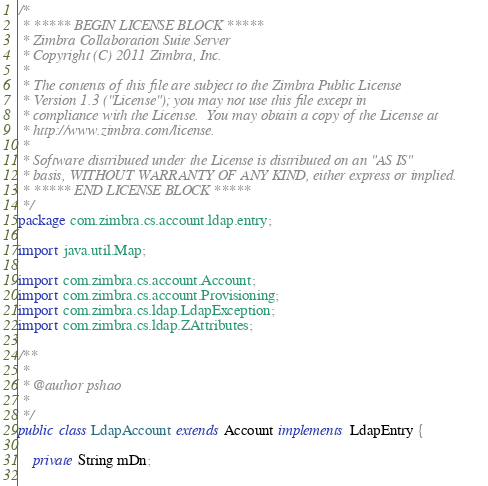Convert code to text. <code><loc_0><loc_0><loc_500><loc_500><_Java_>/*
 * ***** BEGIN LICENSE BLOCK *****
 * Zimbra Collaboration Suite Server
 * Copyright (C) 2011 Zimbra, Inc.
 * 
 * The contents of this file are subject to the Zimbra Public License
 * Version 1.3 ("License"); you may not use this file except in
 * compliance with the License.  You may obtain a copy of the License at
 * http://www.zimbra.com/license.
 * 
 * Software distributed under the License is distributed on an "AS IS"
 * basis, WITHOUT WARRANTY OF ANY KIND, either express or implied.
 * ***** END LICENSE BLOCK *****
 */
package com.zimbra.cs.account.ldap.entry;

import java.util.Map;

import com.zimbra.cs.account.Account;
import com.zimbra.cs.account.Provisioning;
import com.zimbra.cs.ldap.LdapException;
import com.zimbra.cs.ldap.ZAttributes;

/**
 * 
 * @author pshao
 *
 */
public class LdapAccount extends Account implements LdapEntry {

    private String mDn;
    </code> 